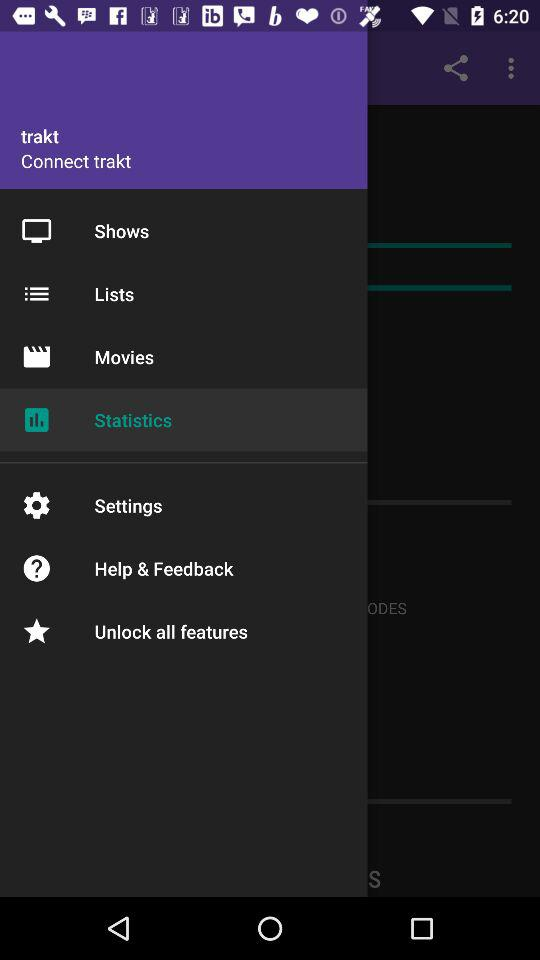What is the selected option? The selected option is Statistics. 